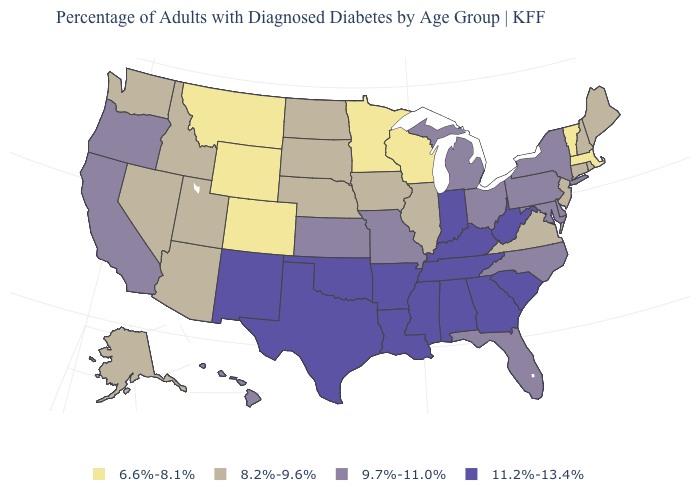What is the value of South Carolina?
Quick response, please. 11.2%-13.4%. Name the states that have a value in the range 8.2%-9.6%?
Give a very brief answer. Alaska, Arizona, Connecticut, Idaho, Illinois, Iowa, Maine, Nebraska, Nevada, New Hampshire, New Jersey, North Dakota, Rhode Island, South Dakota, Utah, Virginia, Washington. Is the legend a continuous bar?
Concise answer only. No. Among the states that border Vermont , does New York have the lowest value?
Answer briefly. No. Does Iowa have the lowest value in the MidWest?
Concise answer only. No. Which states have the lowest value in the MidWest?
Write a very short answer. Minnesota, Wisconsin. Which states have the lowest value in the Northeast?
Keep it brief. Massachusetts, Vermont. What is the highest value in states that border Nevada?
Be succinct. 9.7%-11.0%. Name the states that have a value in the range 8.2%-9.6%?
Quick response, please. Alaska, Arizona, Connecticut, Idaho, Illinois, Iowa, Maine, Nebraska, Nevada, New Hampshire, New Jersey, North Dakota, Rhode Island, South Dakota, Utah, Virginia, Washington. What is the lowest value in the West?
Concise answer only. 6.6%-8.1%. What is the value of Minnesota?
Give a very brief answer. 6.6%-8.1%. What is the value of Wisconsin?
Write a very short answer. 6.6%-8.1%. Name the states that have a value in the range 6.6%-8.1%?
Short answer required. Colorado, Massachusetts, Minnesota, Montana, Vermont, Wisconsin, Wyoming. What is the highest value in the MidWest ?
Short answer required. 11.2%-13.4%. Does Nebraska have a lower value than New Hampshire?
Keep it brief. No. 